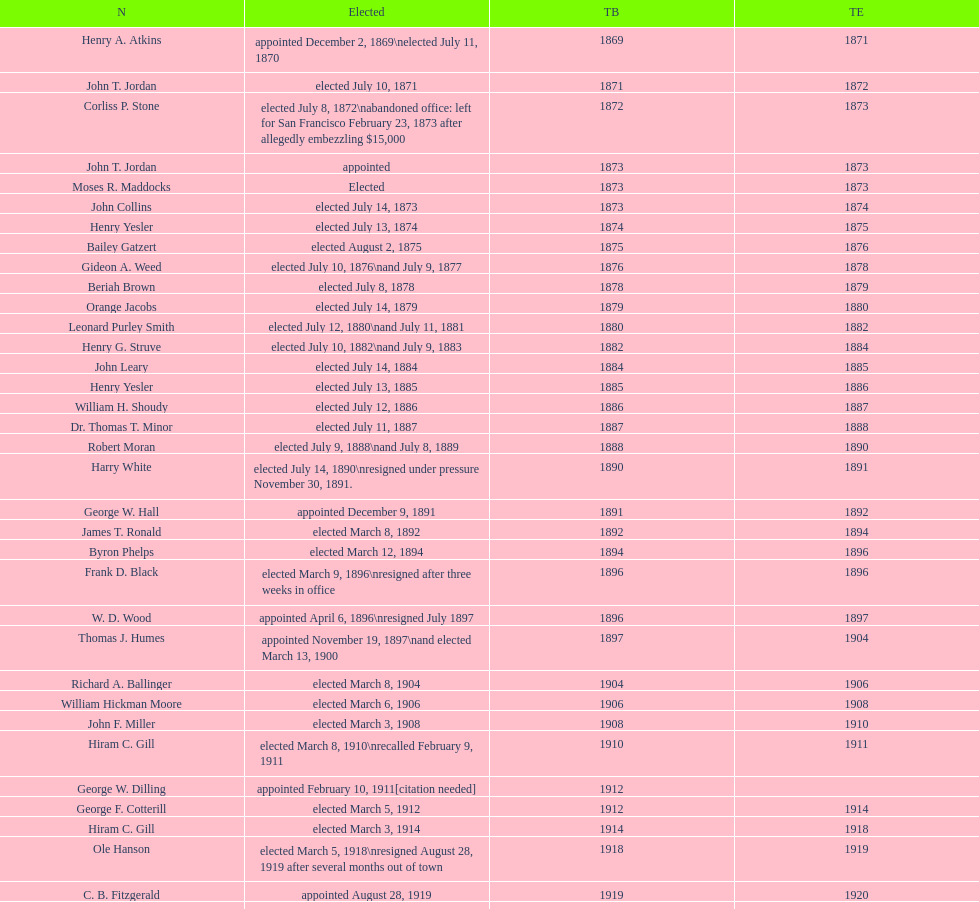Who held the mayoral office in seattle, washington before taking up a role in the department of transportation during nixon's presidency? James d'Orma Braman. 